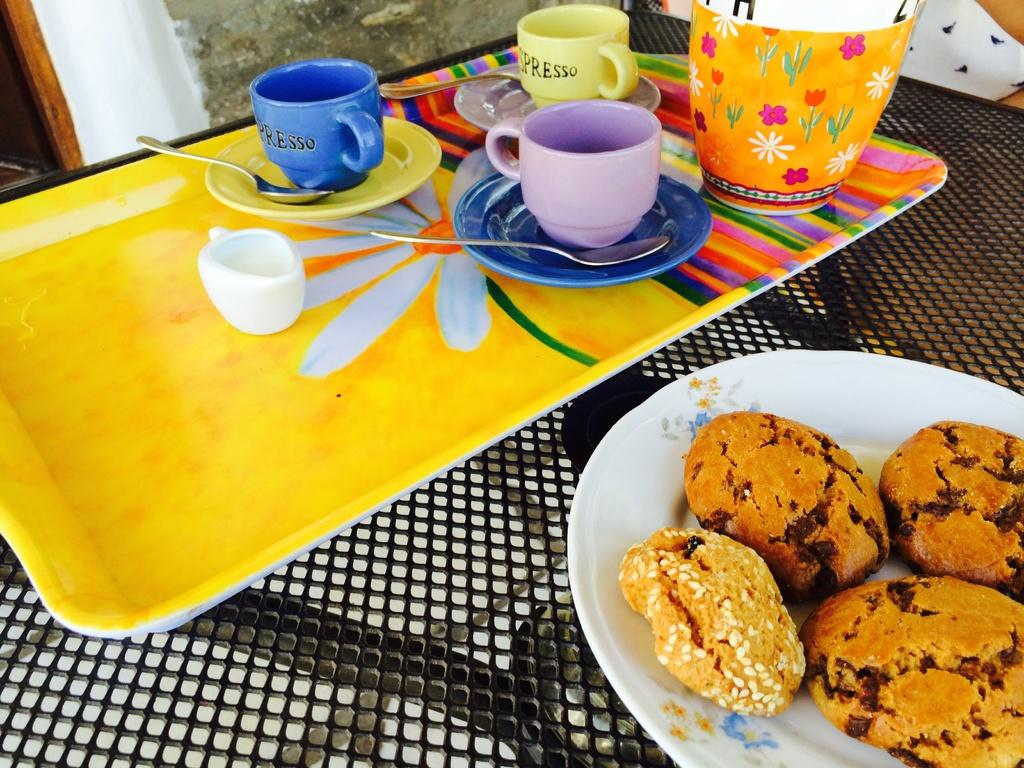What is on the table in the image? There is a tray on the table. What items are on the tray? There is a saucer, a spoon, a cup, and a jar on the tray. Are there any food items visible in the image? Yes, there are cookies on a plate. What can be seen in the background of the image? There is a wall in the background of the image. What type of music is the band playing in the background of the image? There is no band present in the image, so it is not possible to determine what type of music they might be playing. 